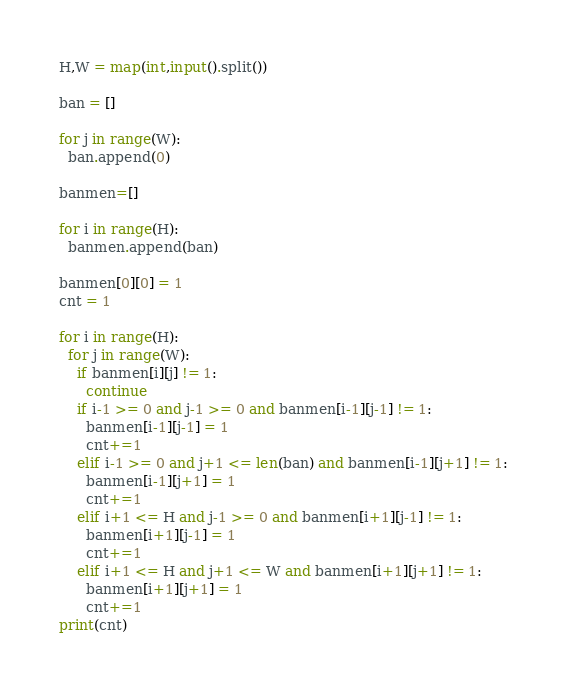Convert code to text. <code><loc_0><loc_0><loc_500><loc_500><_Python_>H,W = map(int,input().split())

ban = []

for j in range(W):
  ban.append(0)

banmen=[]

for i in range(H):
  banmen.append(ban)
  
banmen[0][0] = 1
cnt = 1

for i in range(H):
  for j in range(W):
    if banmen[i][j] != 1:
      continue
    if i-1 >= 0 and j-1 >= 0 and banmen[i-1][j-1] != 1:
      banmen[i-1][j-1] = 1
      cnt+=1
    elif i-1 >= 0 and j+1 <= len(ban) and banmen[i-1][j+1] != 1:
      banmen[i-1][j+1] = 1
      cnt+=1
    elif i+1 <= H and j-1 >= 0 and banmen[i+1][j-1] != 1:
      banmen[i+1][j-1] = 1
      cnt+=1
    elif i+1 <= H and j+1 <= W and banmen[i+1][j+1] != 1:
      banmen[i+1][j+1] = 1
      cnt+=1
print(cnt)</code> 